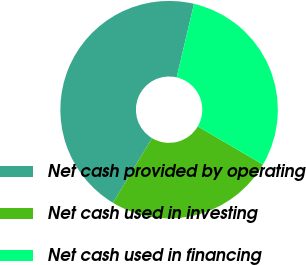<chart> <loc_0><loc_0><loc_500><loc_500><pie_chart><fcel>Net cash provided by operating<fcel>Net cash used in investing<fcel>Net cash used in financing<nl><fcel>45.05%<fcel>25.21%<fcel>29.74%<nl></chart> 